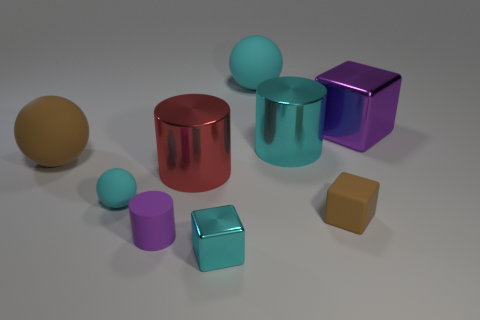Add 1 big cyan rubber cylinders. How many objects exist? 10 Subtract all blocks. How many objects are left? 6 Add 7 large cylinders. How many large cylinders exist? 9 Subtract 0 yellow balls. How many objects are left? 9 Subtract all red metallic objects. Subtract all small purple matte things. How many objects are left? 7 Add 3 large cyan matte balls. How many large cyan matte balls are left? 4 